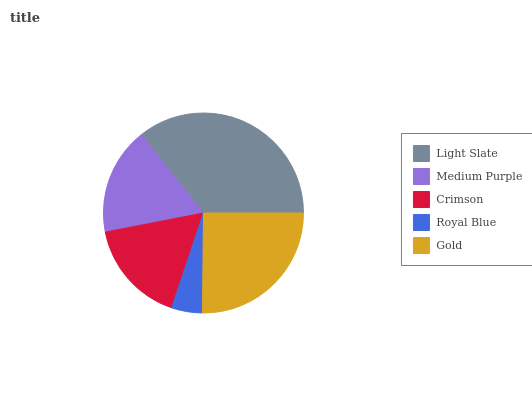Is Royal Blue the minimum?
Answer yes or no. Yes. Is Light Slate the maximum?
Answer yes or no. Yes. Is Medium Purple the minimum?
Answer yes or no. No. Is Medium Purple the maximum?
Answer yes or no. No. Is Light Slate greater than Medium Purple?
Answer yes or no. Yes. Is Medium Purple less than Light Slate?
Answer yes or no. Yes. Is Medium Purple greater than Light Slate?
Answer yes or no. No. Is Light Slate less than Medium Purple?
Answer yes or no. No. Is Medium Purple the high median?
Answer yes or no. Yes. Is Medium Purple the low median?
Answer yes or no. Yes. Is Royal Blue the high median?
Answer yes or no. No. Is Royal Blue the low median?
Answer yes or no. No. 